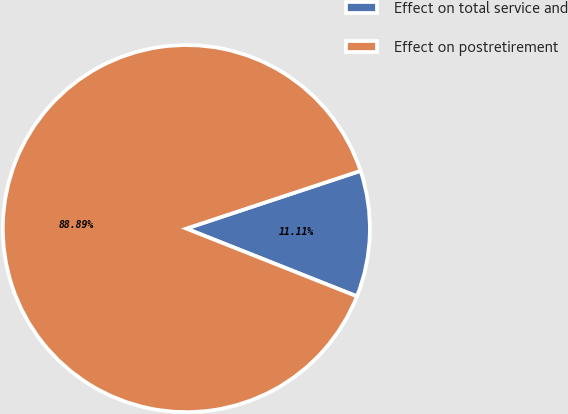<chart> <loc_0><loc_0><loc_500><loc_500><pie_chart><fcel>Effect on total service and<fcel>Effect on postretirement<nl><fcel>11.11%<fcel>88.89%<nl></chart> 